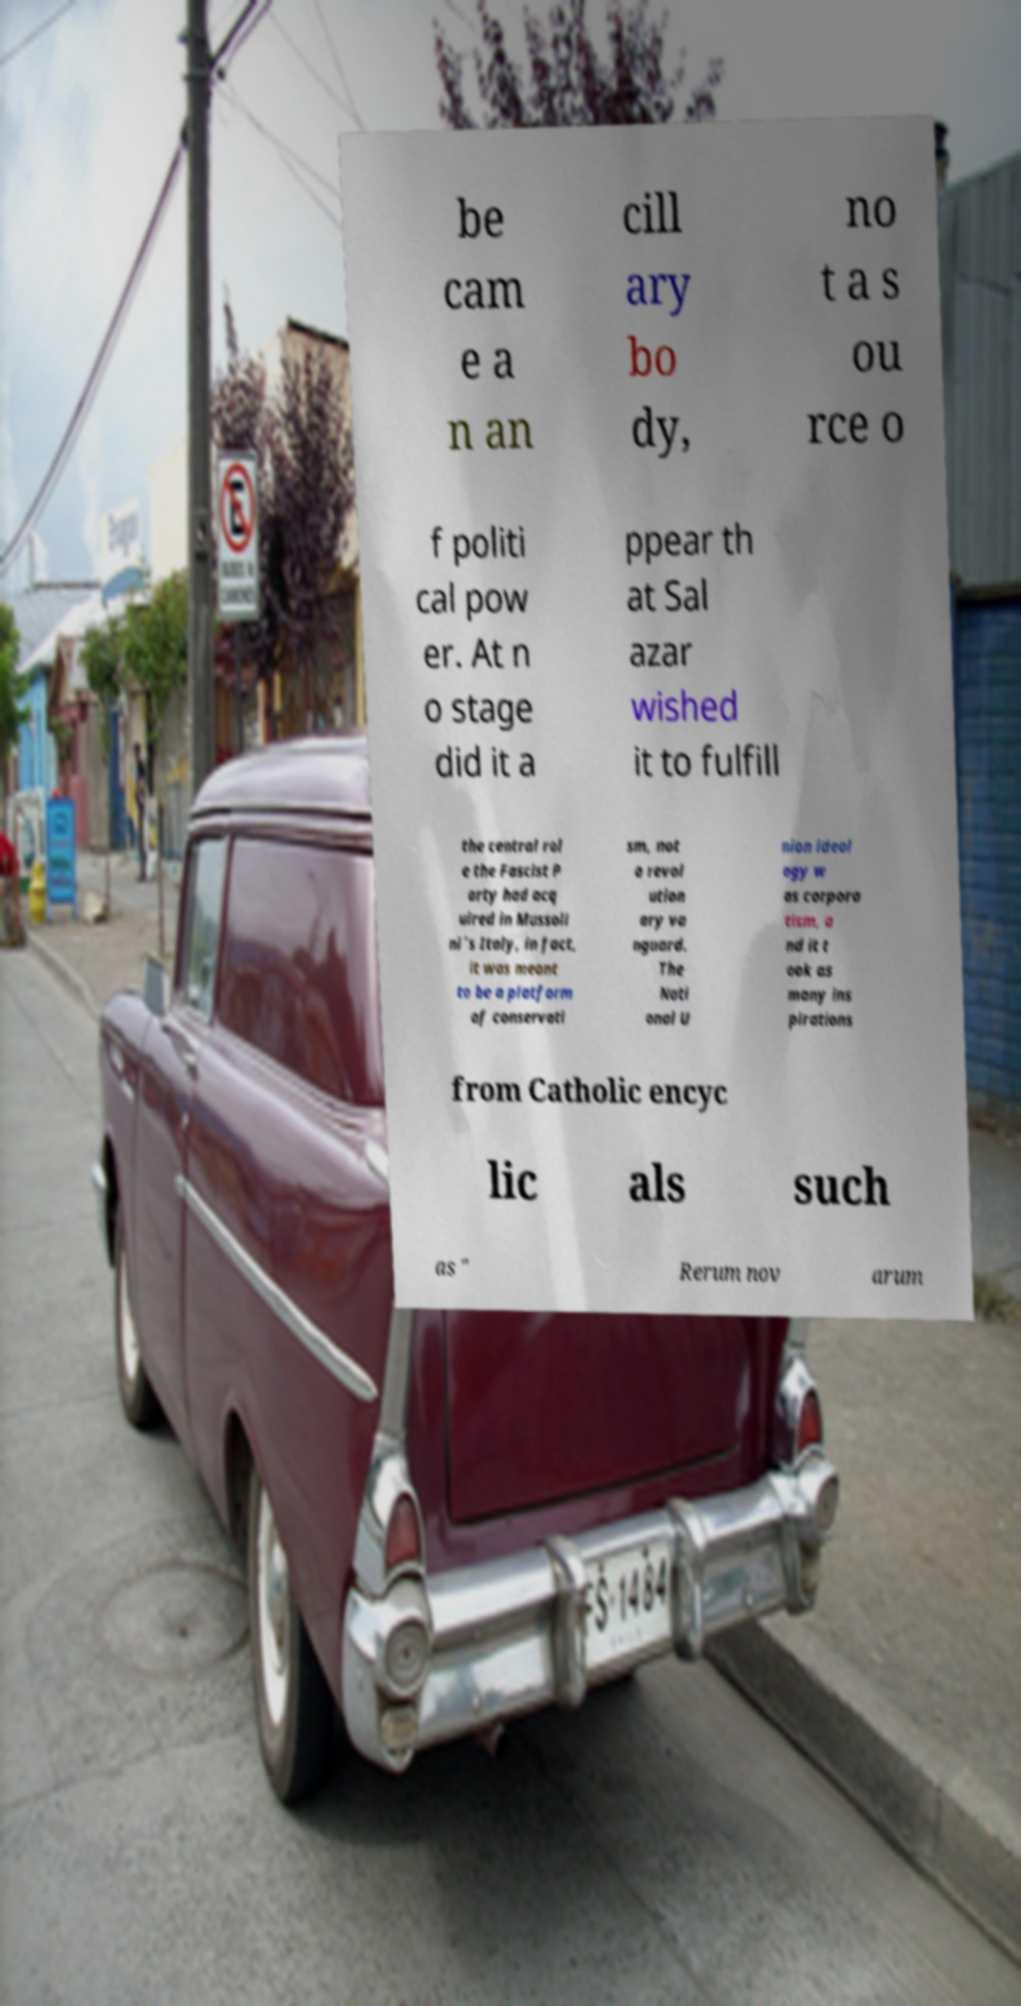Could you assist in decoding the text presented in this image and type it out clearly? be cam e a n an cill ary bo dy, no t a s ou rce o f politi cal pow er. At n o stage did it a ppear th at Sal azar wished it to fulfill the central rol e the Fascist P arty had acq uired in Mussoli ni´s Italy, in fact, it was meant to be a platform of conservati sm, not a revol ution ary va nguard. The Nati onal U nion ideol ogy w as corpora tism, a nd it t ook as many ins pirations from Catholic encyc lic als such as " Rerum nov arum 